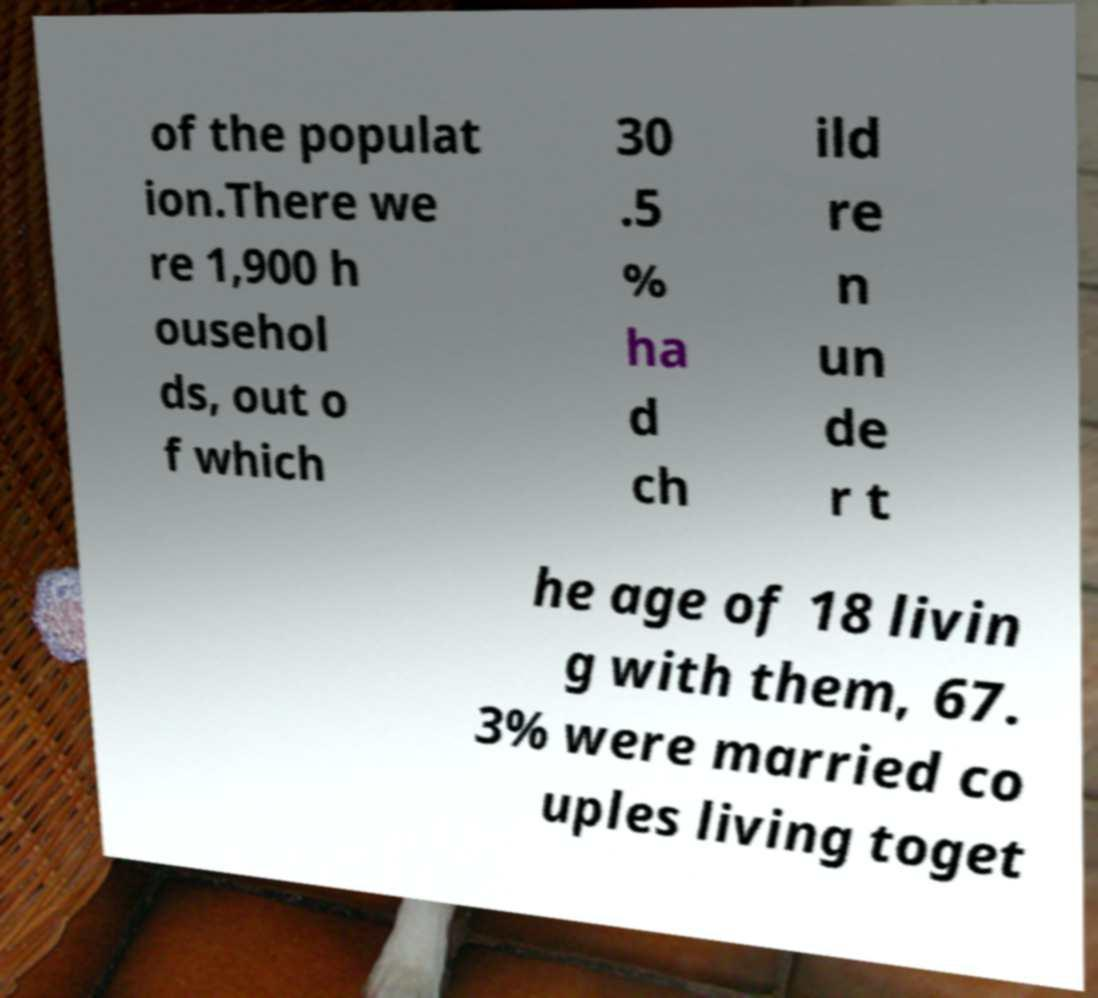Could you extract and type out the text from this image? of the populat ion.There we re 1,900 h ousehol ds, out o f which 30 .5 % ha d ch ild re n un de r t he age of 18 livin g with them, 67. 3% were married co uples living toget 